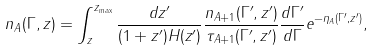Convert formula to latex. <formula><loc_0><loc_0><loc_500><loc_500>n _ { A } ( \Gamma , z ) = \int _ { z } ^ { z _ { \max } } \frac { d z ^ { \prime } } { ( 1 + z ^ { \prime } ) H ( z ^ { \prime } ) } \frac { n _ { A + 1 } ( \Gamma ^ { \prime } , z ^ { \prime } ) } { \tau _ { A + 1 } ( \Gamma ^ { \prime } , z ^ { \prime } ) } \frac { d \Gamma ^ { \prime } } { d \Gamma } e ^ { - \eta _ { A } ( \Gamma ^ { \prime } , z ^ { \prime } ) } ,</formula> 